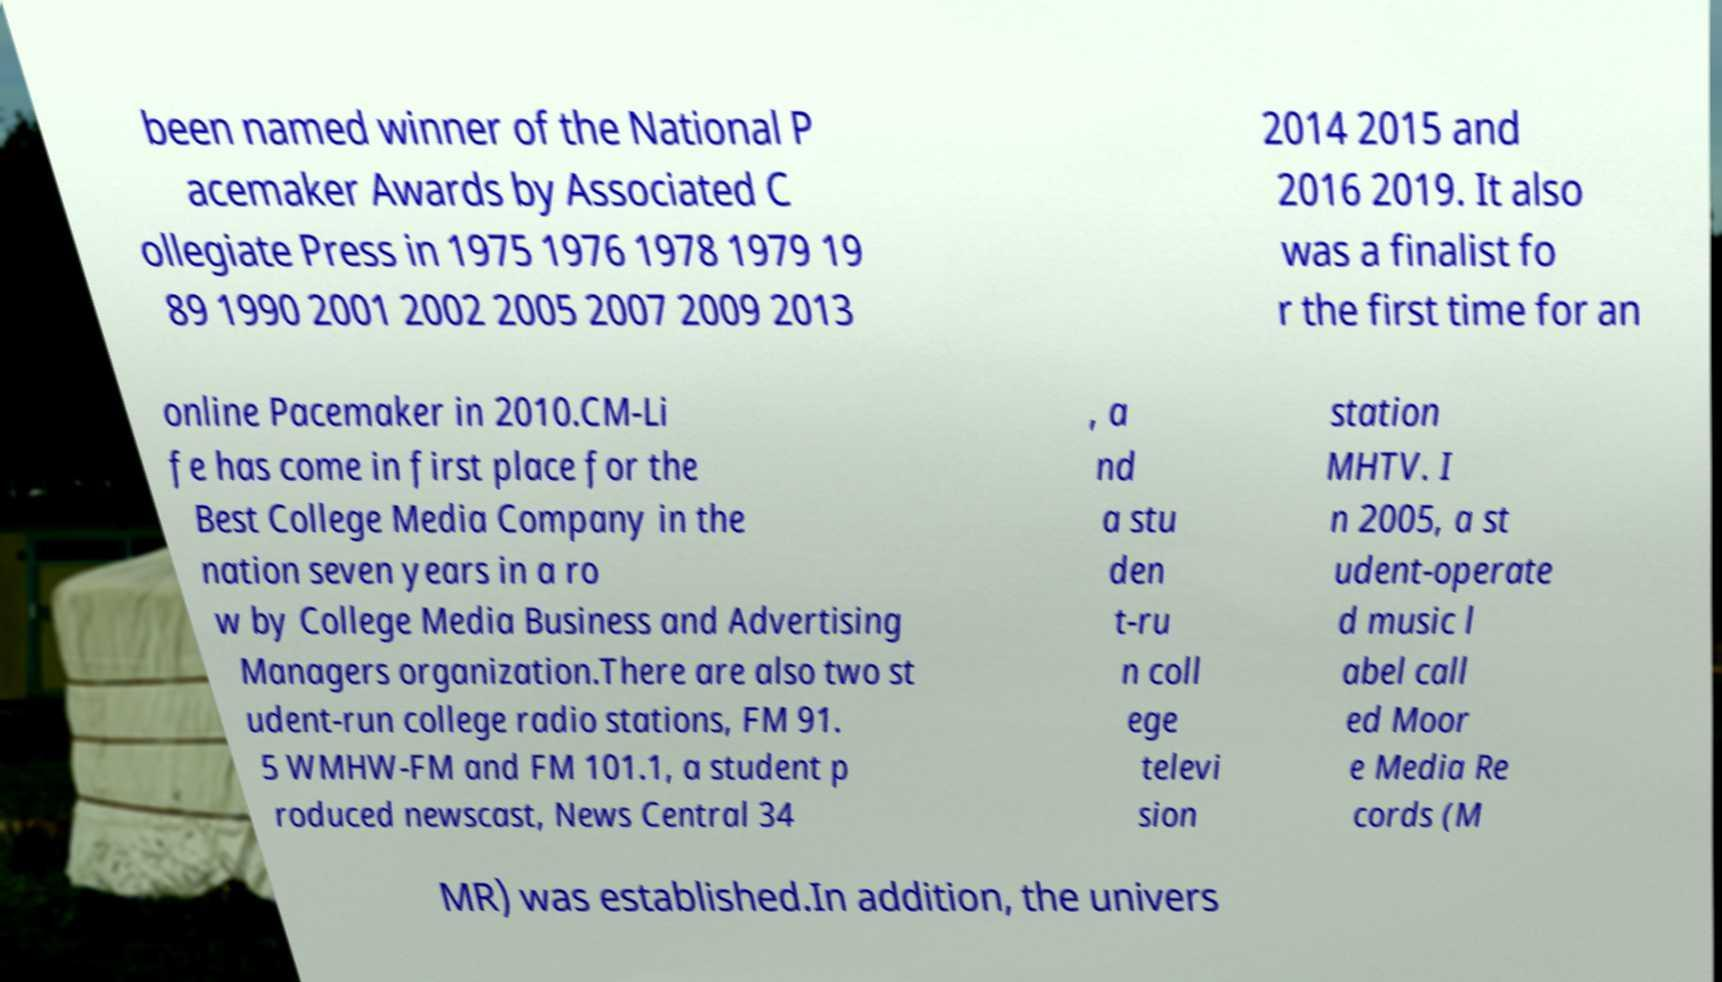For documentation purposes, I need the text within this image transcribed. Could you provide that? been named winner of the National P acemaker Awards by Associated C ollegiate Press in 1975 1976 1978 1979 19 89 1990 2001 2002 2005 2007 2009 2013 2014 2015 and 2016 2019. It also was a finalist fo r the first time for an online Pacemaker in 2010.CM-Li fe has come in first place for the Best College Media Company in the nation seven years in a ro w by College Media Business and Advertising Managers organization.There are also two st udent-run college radio stations, FM 91. 5 WMHW-FM and FM 101.1, a student p roduced newscast, News Central 34 , a nd a stu den t-ru n coll ege televi sion station MHTV. I n 2005, a st udent-operate d music l abel call ed Moor e Media Re cords (M MR) was established.In addition, the univers 